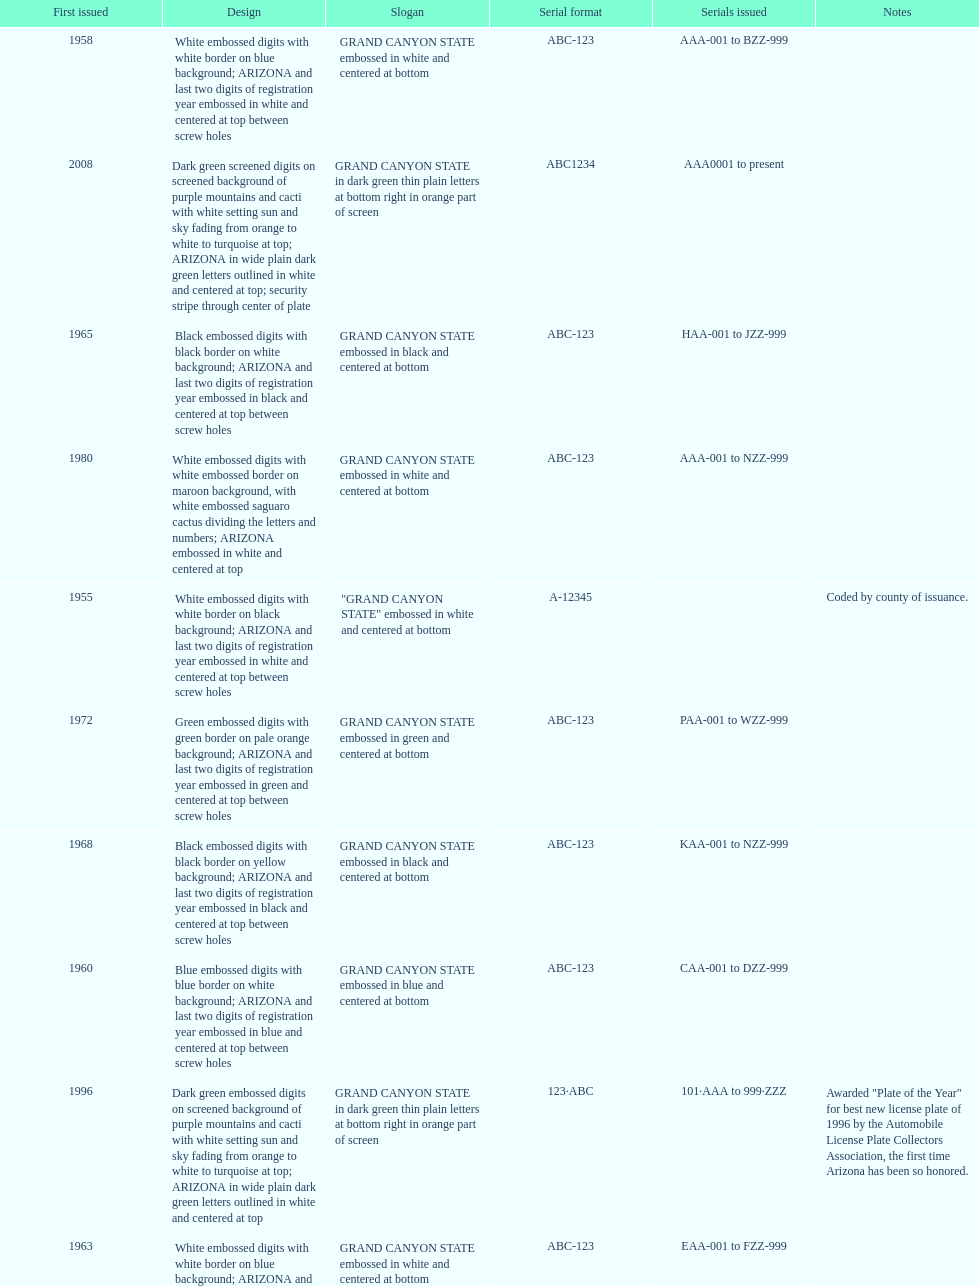What is the average serial format of the arizona license plates? ABC-123. 